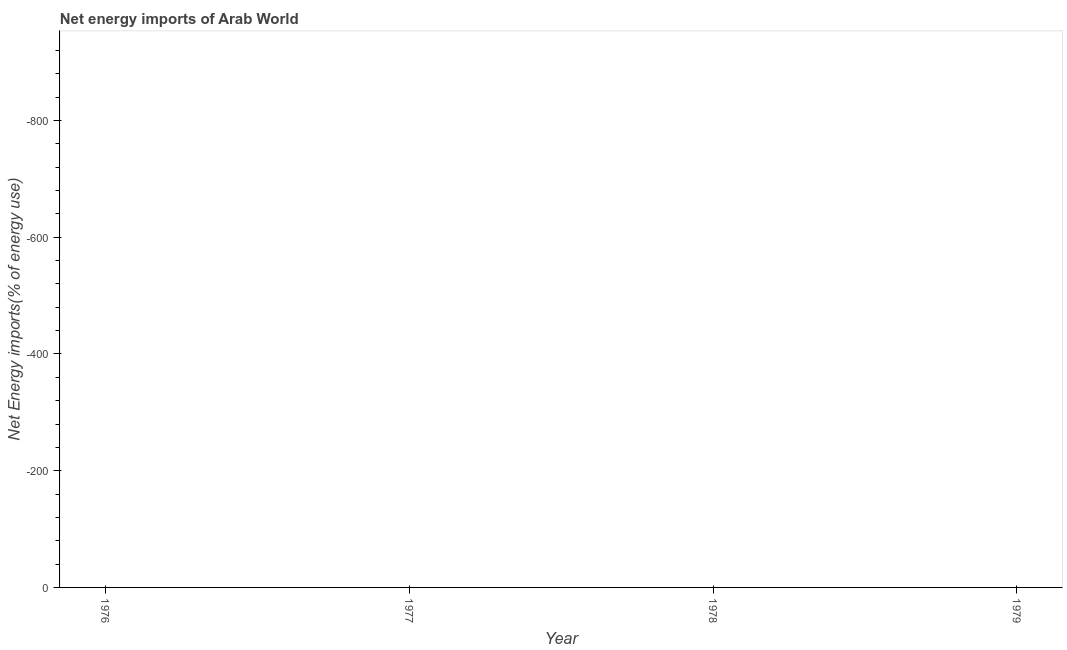Across all years, what is the minimum energy imports?
Offer a terse response. 0. In how many years, is the energy imports greater than -40 %?
Provide a succinct answer. 0. In how many years, is the energy imports greater than the average energy imports taken over all years?
Give a very brief answer. 0. Does the energy imports monotonically increase over the years?
Give a very brief answer. Yes. How many lines are there?
Your response must be concise. 0. What is the difference between two consecutive major ticks on the Y-axis?
Your answer should be very brief. 200. Are the values on the major ticks of Y-axis written in scientific E-notation?
Give a very brief answer. No. What is the title of the graph?
Make the answer very short. Net energy imports of Arab World. What is the label or title of the X-axis?
Your response must be concise. Year. What is the label or title of the Y-axis?
Make the answer very short. Net Energy imports(% of energy use). What is the Net Energy imports(% of energy use) of 1977?
Provide a short and direct response. 0. 